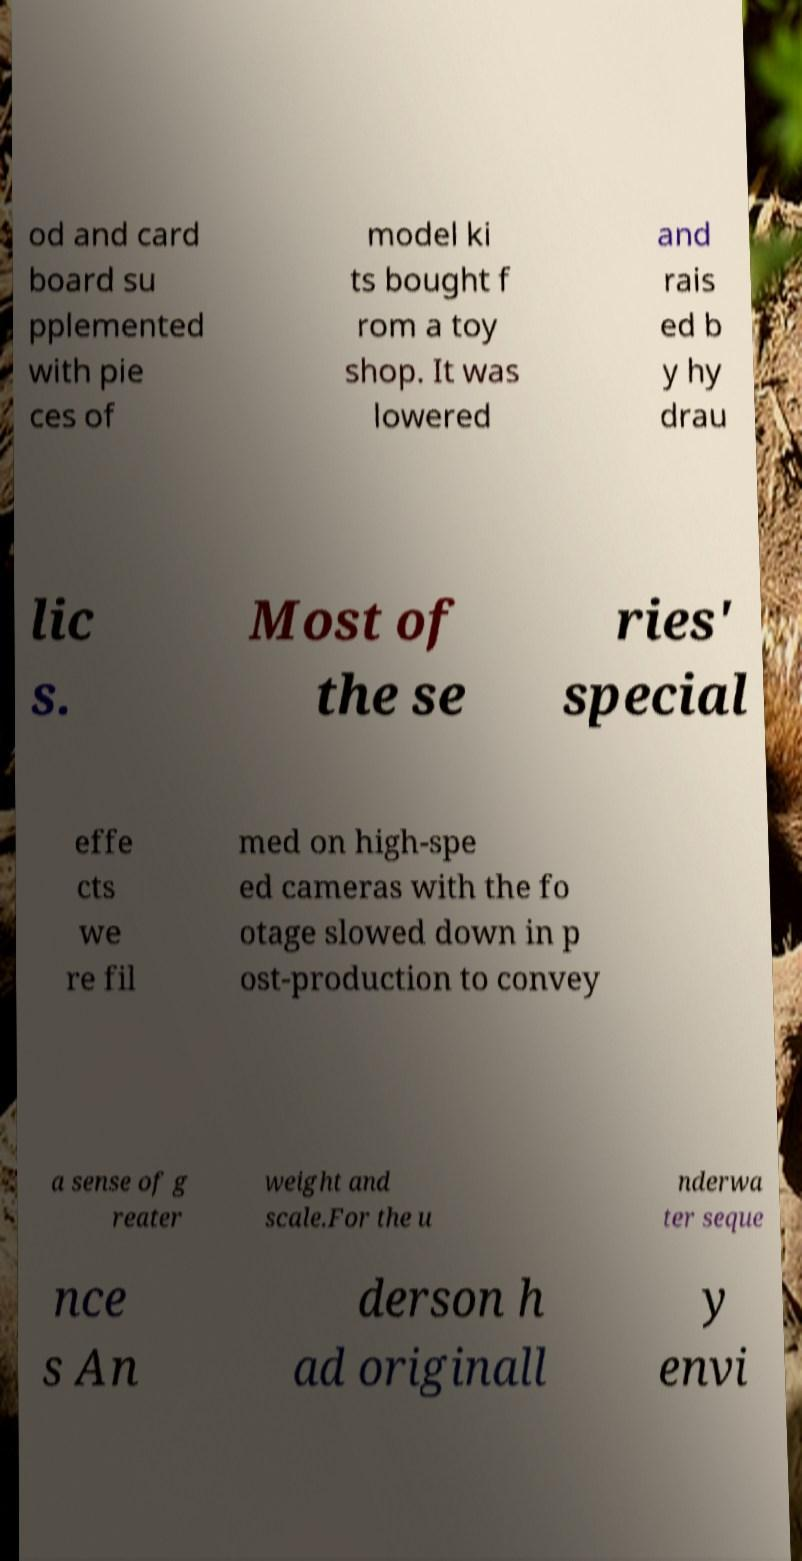I need the written content from this picture converted into text. Can you do that? od and card board su pplemented with pie ces of model ki ts bought f rom a toy shop. It was lowered and rais ed b y hy drau lic s. Most of the se ries' special effe cts we re fil med on high-spe ed cameras with the fo otage slowed down in p ost-production to convey a sense of g reater weight and scale.For the u nderwa ter seque nce s An derson h ad originall y envi 